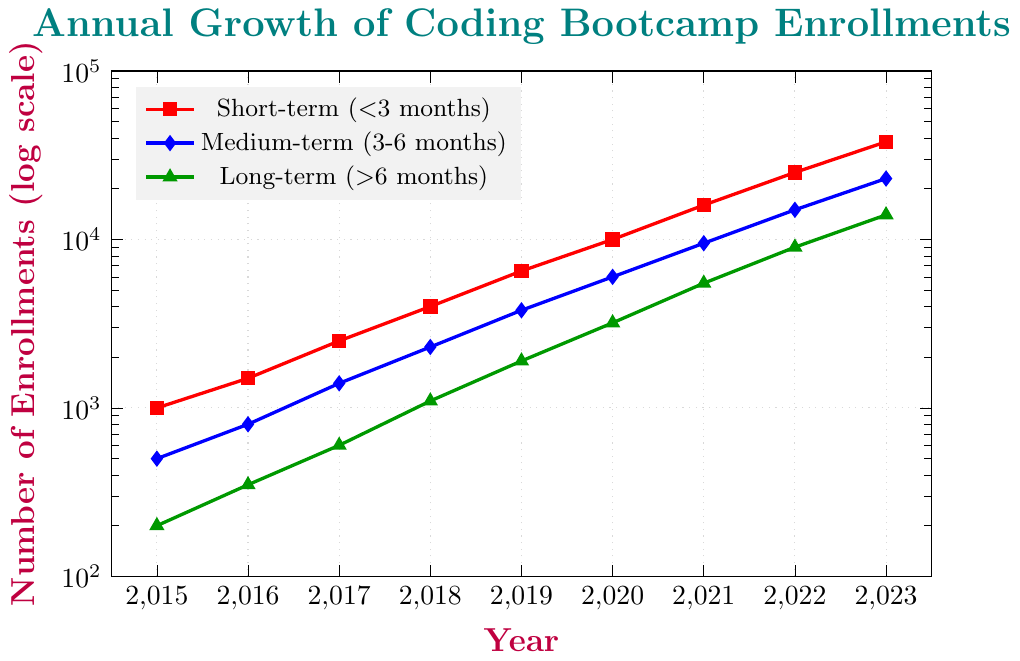What is the general trend in the number of enrollments for short-term bootcamps over the years? The number of enrollments for short-term bootcamps has been increasing over the years. Starting from 1000 in 2015 and increasing to 38000 in 2023.
Answer: Increasing Which program duration showed the highest number of enrollments in 2023? In 2023, the short-term program has the highest number of enrollments as indicated by the red line reaching 38000, compared to the blue line for medium-term at 23000 and the green line for long-term at 14000.
Answer: Short-term How many times did the enrollments for long-term programs increase from 2015 to 2023? In 2015, the number of enrollments for long-term programs was 200. By 2023, it increased to 14000. To find the multiple, we calculate 14000 / 200 = 70. So, the enrollments increased 70 times.
Answer: 70 times Compare the growth in enrollments between short-term and medium-term programs from 2020 to 2023. Which one grew more? For short-term programs, enrollments grew from 10000 in 2020 to 38000 in 2023, an increase of 28000. For medium-term programs, enrollments grew from 6000 in 2020 to 23000 in 2023, an increase of 17000. Therefore, the short-term programs grew more.
Answer: Short-term What is the ratio of the number of enrollments in short-term vs long-term programs in 2021? In 2021, the number of enrollments in short-term programs is 16000 and in long-term programs is 5500. The ratio is 16000 / 5500 = 16/5 ≈ 2.91.
Answer: Approximately 2.91 What is the overall trend in the enrollment numbers for medium-term bootcamps between 2015 and 2023 based on the visual scale? The enrollment numbers for medium-term bootcamps show a consistent upward trend from 500 in 2015 to 23000 in 2023, a significant increase in a near-exponential manner.
Answer: Increasing What was the enrollment difference between short-term and long-term programs in 2019? In 2019, the short-term program enrollments were 6500 and long-term program enrollments were 1900. The difference is 6500 - 1900 = 4600.
Answer: 4600 If you were to predict the enrollment numbers for long-term programs in 2024 based on the trend, what would your estimate be? Based on the increasing trend of enrollments from 200 in 2015 to 14000 in 2023, and considering the exponential growth pattern seen in the graph, the enrollment for long-term programs in 2024 could be estimated around 20000 if the trend continues similarly.
Answer: Approximately 20000 